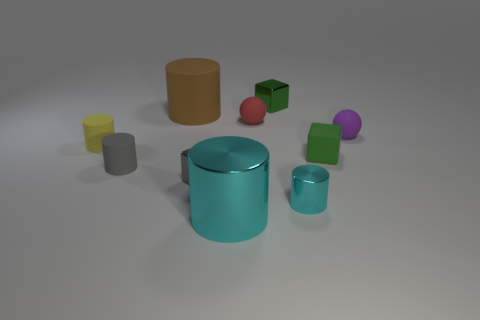Subtract all large cyan cylinders. How many cylinders are left? 4 Subtract all gray cylinders. How many cylinders are left? 4 Subtract 1 cylinders. How many cylinders are left? 4 Subtract all brown cylinders. Subtract all gray spheres. How many cylinders are left? 4 Subtract all cyan spheres. How many red cylinders are left? 0 Subtract all brown metal objects. Subtract all rubber things. How many objects are left? 4 Add 3 large matte things. How many large matte things are left? 4 Add 3 red spheres. How many red spheres exist? 4 Subtract 1 purple balls. How many objects are left? 9 Subtract all cubes. How many objects are left? 7 